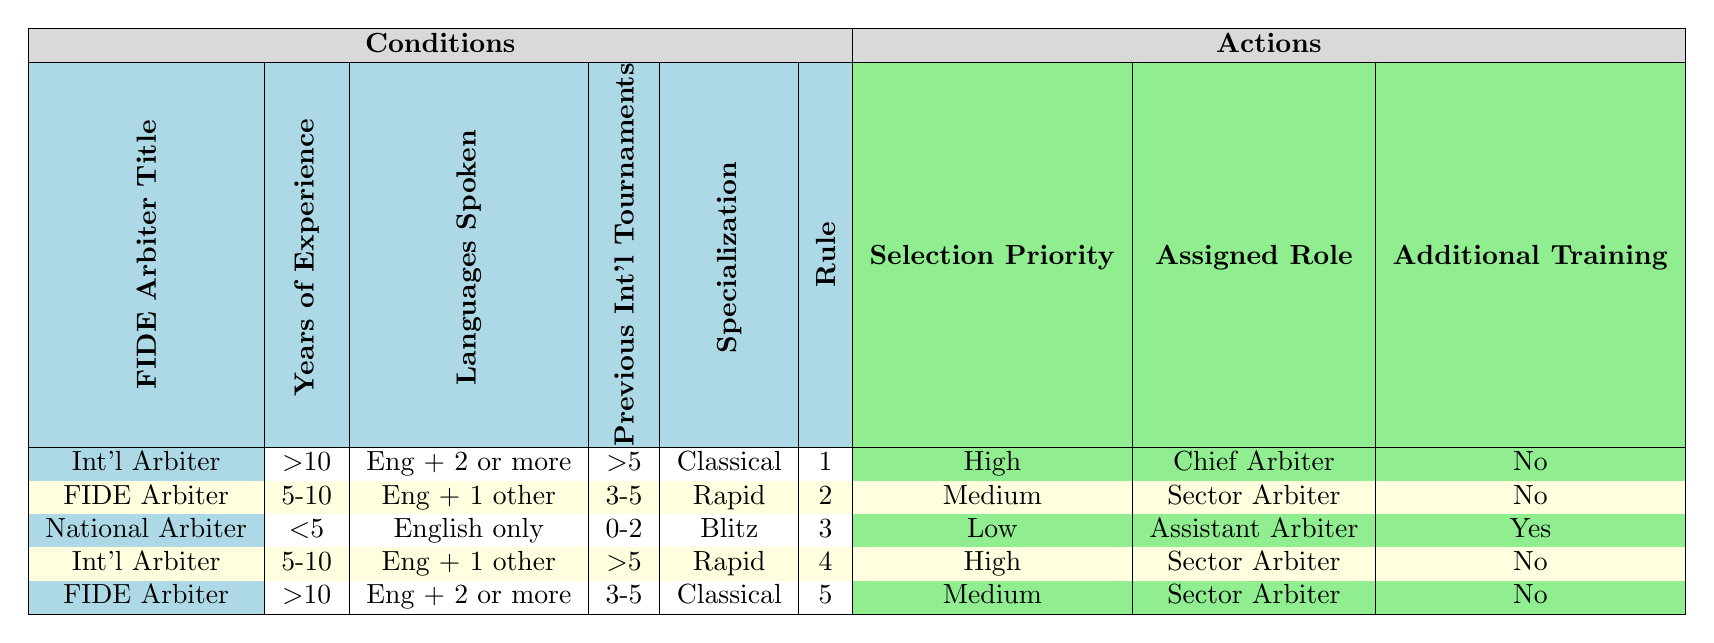What is the selection priority for an International Arbiter with more than 10 years of experience who speaks English and two or more languages and has participated in more than five international tournaments specializing in Classical chess? The table shows that for an International Arbiter with more than 10 years of experience, English + 2 or more languages, more than 5 international tournaments, and specialization in Classical chess, the selection priority is marked as High.
Answer: High How many different roles are assigned to National Arbiters based on the table? From the table, there is only one assigned role for the National Arbiter in the third row, which is Assistant Arbiter. Therefore, there is only one unique role represented for National Arbiters.
Answer: 1 Does an arbiter who is a FIDE Arbiter with less than five years of experience have a high selection priority? In the table, there is no FIDE Arbiter with less than five years of experience listed. Thus, one can conclude that since there are no such arbiters, the question is invalid in that context.
Answer: No Which specialization has the highest selection priority and what is the assigned role? The row concerning the International Arbiter with more than 10 years of experience specializing in Classical chess indicates a high selection priority, with the assigned role being Chief Arbiter.
Answer: Chief Arbiter What is the average years of experience of arbiters who have a Medium selection priority? The arbiters assigned Medium selection priority are those in the second and fifth rows, which correspond to 5-10 years of experience. Therefore, since both arbiters have 5-10 years of experience, we can estimate this range as the average years of experience.
Answer: 5-10 Is there any case of an Assistant Arbiter who also requires additional training? According to the table, the National Arbiter with less than five years of experience and specializing in Blitz has the assigned role of Assistant Arbiter and also requires additional training. Therefore, there is indeed such a case.
Answer: Yes What is the total number of arbiters listed in the table who have more than five previous international tournaments? There are two rows in the table where arbiters have more than five previous international tournaments: the first row (International Arbiter, more than 10 years of experience) and the fourth row (International Arbiter, 5-10 years of experience). Hence, the total is two arbiters.
Answer: 2 Which FIDE Arbiter has the highest level of experience and what is their assigned role? The highest level of experience for FIDE Arbiters as per the table is indicated in the fifth row, with more than 10 years of experience, and their assigned role is Sector Arbiter.
Answer: Sector Arbiter 